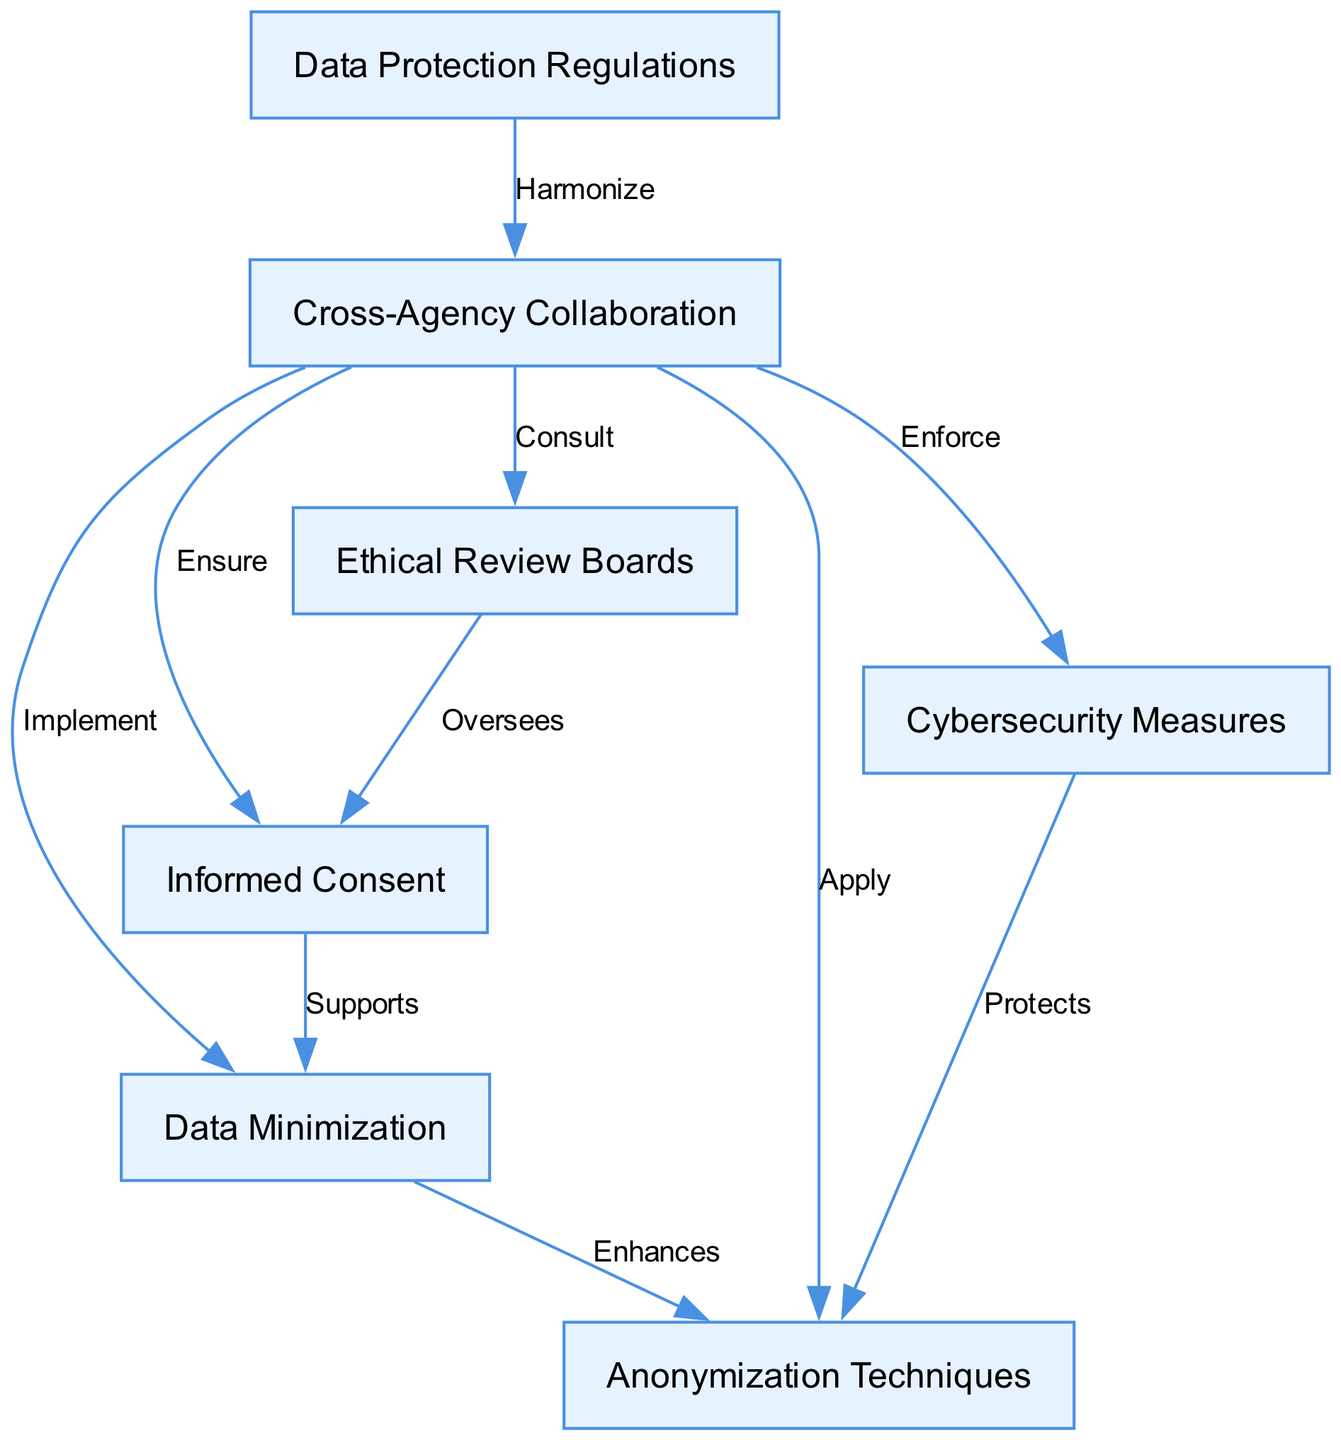What is the total number of nodes in the diagram? The diagram lists a total of seven unique identifiers for nodes, which represent different concepts or components related to ethical considerations in data sharing and privacy protection. These nodes are: Data Protection Regulations, Cross-Agency Collaboration, Informed Consent, Data Minimization, Anonymization Techniques, Ethical Review Boards, and Cybersecurity Measures.
Answer: 7 What node is directly connected to "Cross-Agency Collaboration"? The node "Cross-Agency Collaboration" has multiple outgoing edges connecting it to other nodes, specifically: Informed Consent, Data Minimization, Anonymization Techniques, Ethical Review Boards, and Cybersecurity Measures. This indicates its central role in the diagram's structure, but the specific node that is directly next to it depends on the edge direction.
Answer: Informed Consent, Data Minimization, Anonymization Techniques, Ethical Review Boards, Cybersecurity Measures Which node is involved in overseeing informed consent? The diagram indicates that "Ethical Review Boards" are responsible for overseeing "Informed Consent." This connection suggests that Ethical Review Boards play a crucial role in ensuring that consent is obtained ethically when sharing data.
Answer: Ethical Review Boards How many edges are there between nodes in the diagram? By counting the visual connections (edges) in the diagram, we see that there are 10 distinct edges indicating relationships between the various nodes. Each edge represents an action or relationship that connects different ethical considerations.
Answer: 10 What relationship connects "Data Protection Regulations" to "Cross-Agency Collaboration"? In the diagram, the relationship between "Data Protection Regulations" and "Cross-Agency Collaboration" is labeled "Harmonize." This suggests that there is a need for alignment or standardization between different regulatory frameworks.
Answer: Harmonize How does "Data Minimization" enhance "Anonymization Techniques"? The diagram presents a direct edge from "Data Minimization" to "Anonymization Techniques," which is labeled "Enhances." This indicates that applying data minimization principles contributes positively to the effectiveness of anonymization methods.
Answer: Enhances Which two nodes are linked by an edge labeled "Ensure"? The edge labeled "Ensure" connects "Cross-Agency Collaboration" with "Informed Consent." This labeling implies that collaboration among agencies is essential for guaranteeing the ethical procurement of informed consent.
Answer: Cross-Agency Collaboration, Informed Consent What is the relationship expressed between "Cybersecurity Measures" and "Anonymization Techniques"? The relationship is labeled "Protects," indicating that the implementation of cybersecurity measures provides protective benefits for the utilization and integrity of anonymization techniques. This reflects a layered approach to protecting data privacy.
Answer: Protects 